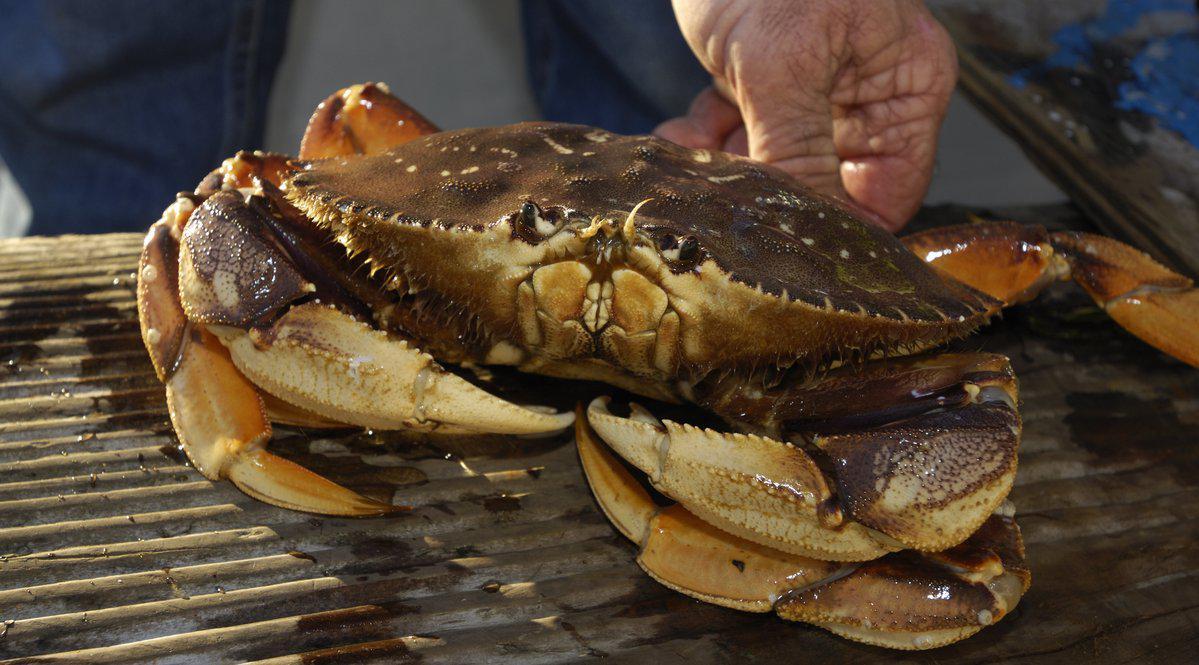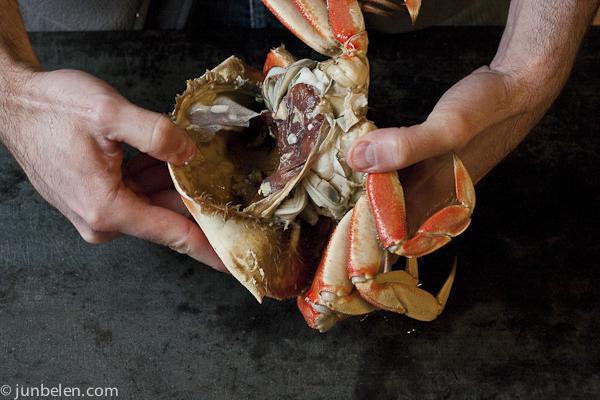The first image is the image on the left, the second image is the image on the right. Given the left and right images, does the statement "One image shows a hand next to the top of an intact crab, and the other image shows two hands tearing a crab in two." hold true? Answer yes or no. Yes. 